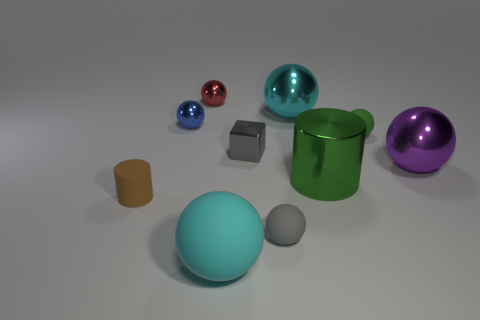Subtract all cyan balls. How many balls are left? 5 Subtract all small green balls. How many balls are left? 6 Subtract all purple spheres. Subtract all brown cylinders. How many spheres are left? 6 Subtract all cubes. How many objects are left? 9 Add 1 large purple shiny spheres. How many large purple shiny spheres are left? 2 Add 1 tiny yellow shiny cylinders. How many tiny yellow shiny cylinders exist? 1 Subtract 0 red blocks. How many objects are left? 10 Subtract all matte spheres. Subtract all tiny blue spheres. How many objects are left? 6 